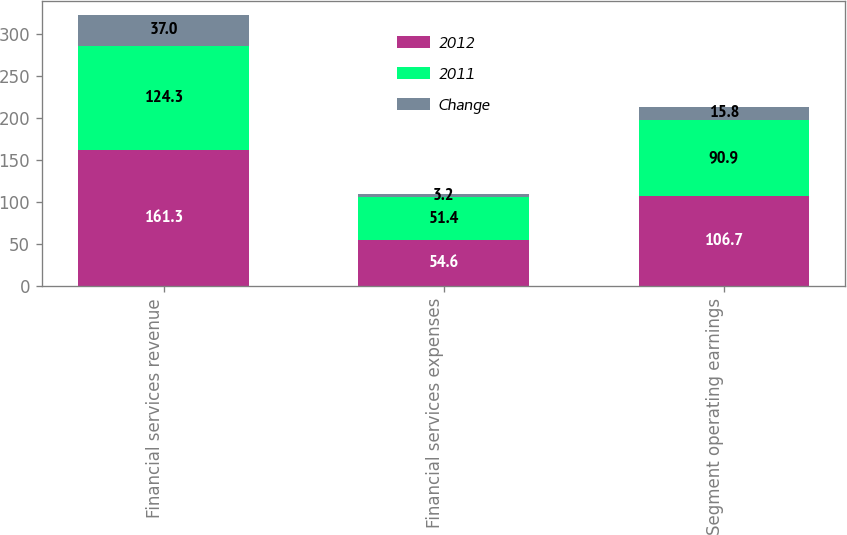<chart> <loc_0><loc_0><loc_500><loc_500><stacked_bar_chart><ecel><fcel>Financial services revenue<fcel>Financial services expenses<fcel>Segment operating earnings<nl><fcel>2012<fcel>161.3<fcel>54.6<fcel>106.7<nl><fcel>2011<fcel>124.3<fcel>51.4<fcel>90.9<nl><fcel>Change<fcel>37<fcel>3.2<fcel>15.8<nl></chart> 